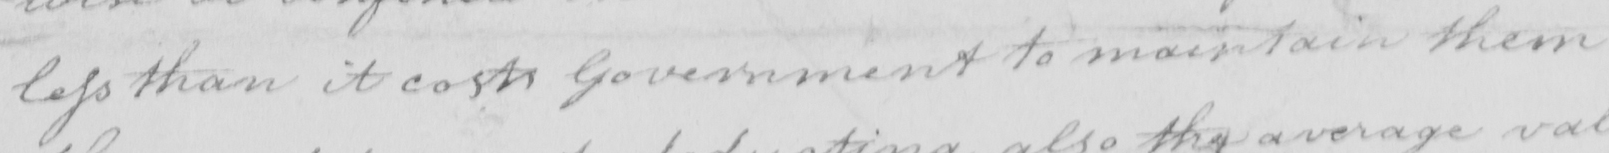Can you read and transcribe this handwriting? less than it costs Government to maintain them 